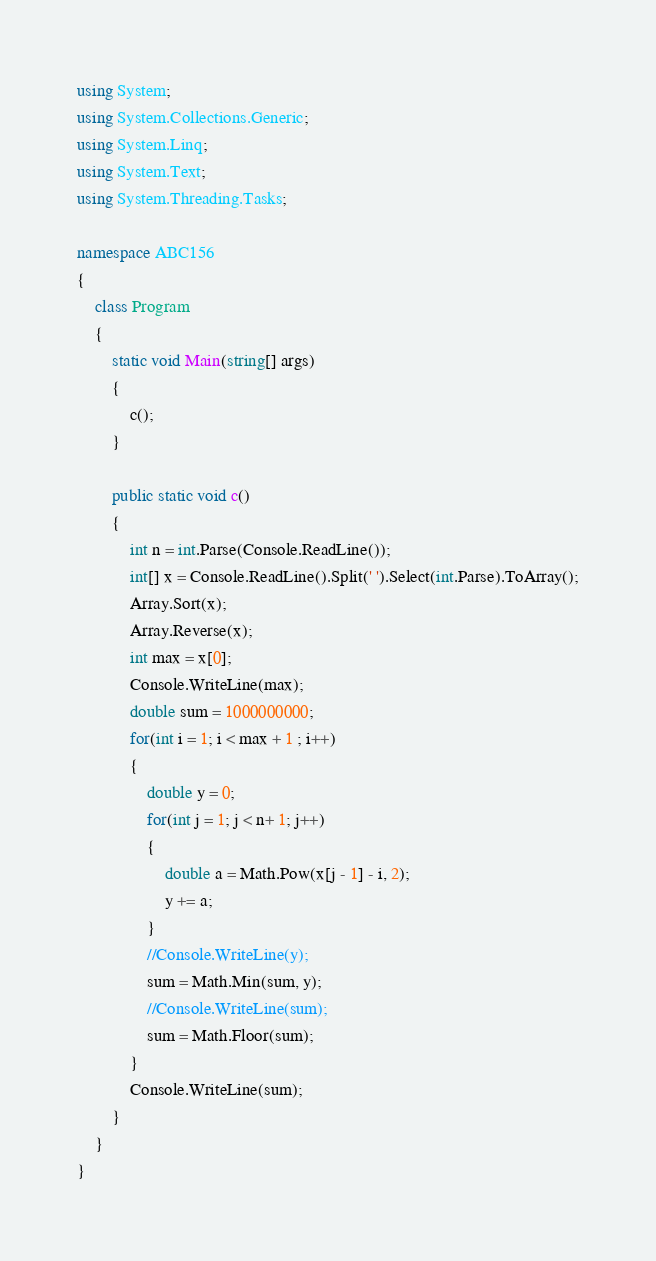<code> <loc_0><loc_0><loc_500><loc_500><_C#_>using System;
using System.Collections.Generic;
using System.Linq;
using System.Text;
using System.Threading.Tasks;

namespace ABC156
{
    class Program
    {
        static void Main(string[] args)
        {
            c();
        }
        
        public static void c()
        {
            int n = int.Parse(Console.ReadLine());
            int[] x = Console.ReadLine().Split(' ').Select(int.Parse).ToArray();
            Array.Sort(x);
            Array.Reverse(x);
            int max = x[0];
            Console.WriteLine(max);
            double sum = 1000000000;
            for(int i = 1; i < max + 1 ; i++)
            {
                double y = 0;
                for(int j = 1; j < n+ 1; j++)
                {
                    double a = Math.Pow(x[j - 1] - i, 2);
                    y += a;
                }
                //Console.WriteLine(y);
                sum = Math.Min(sum, y);
                //Console.WriteLine(sum);
                sum = Math.Floor(sum);
            }
            Console.WriteLine(sum);
        }
    }
}
</code> 